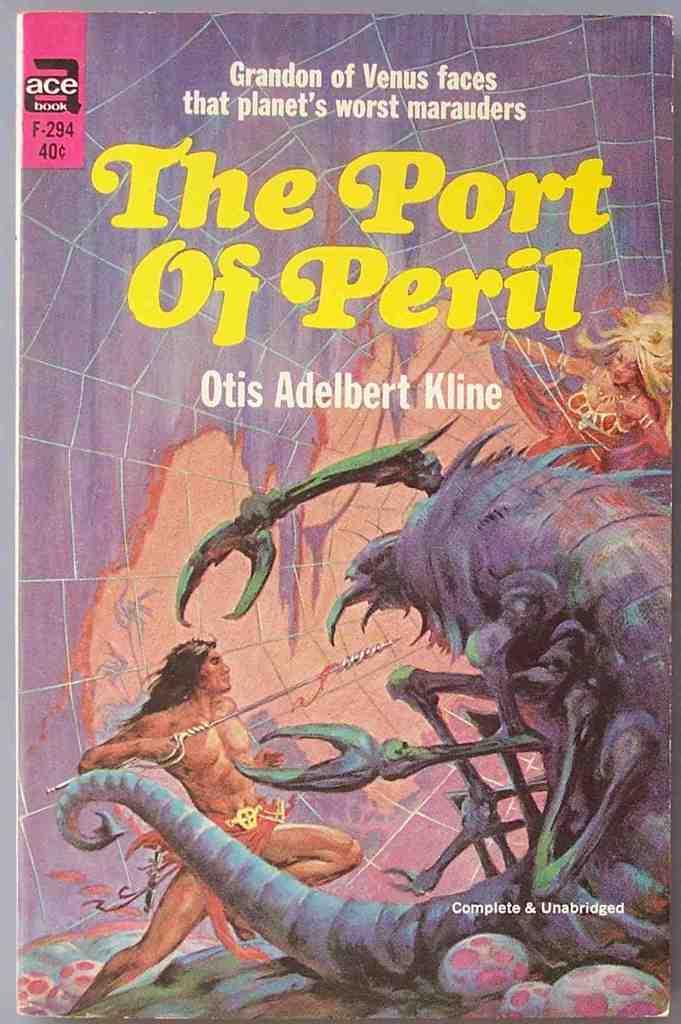Who is the author of this book?
Ensure brevity in your answer.  Otis adelbert kline. 